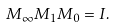Convert formula to latex. <formula><loc_0><loc_0><loc_500><loc_500>M _ { \infty } M _ { 1 } M _ { 0 } = I .</formula> 